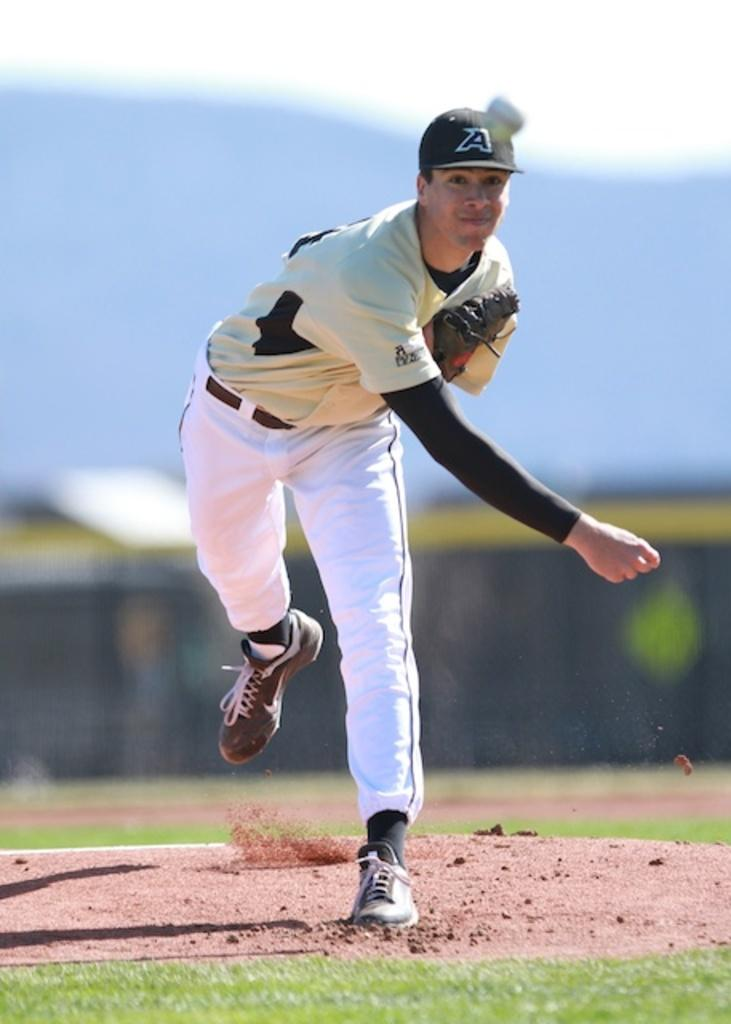<image>
Summarize the visual content of the image. A baseball pitcher with an A on his hat throws a ball. 